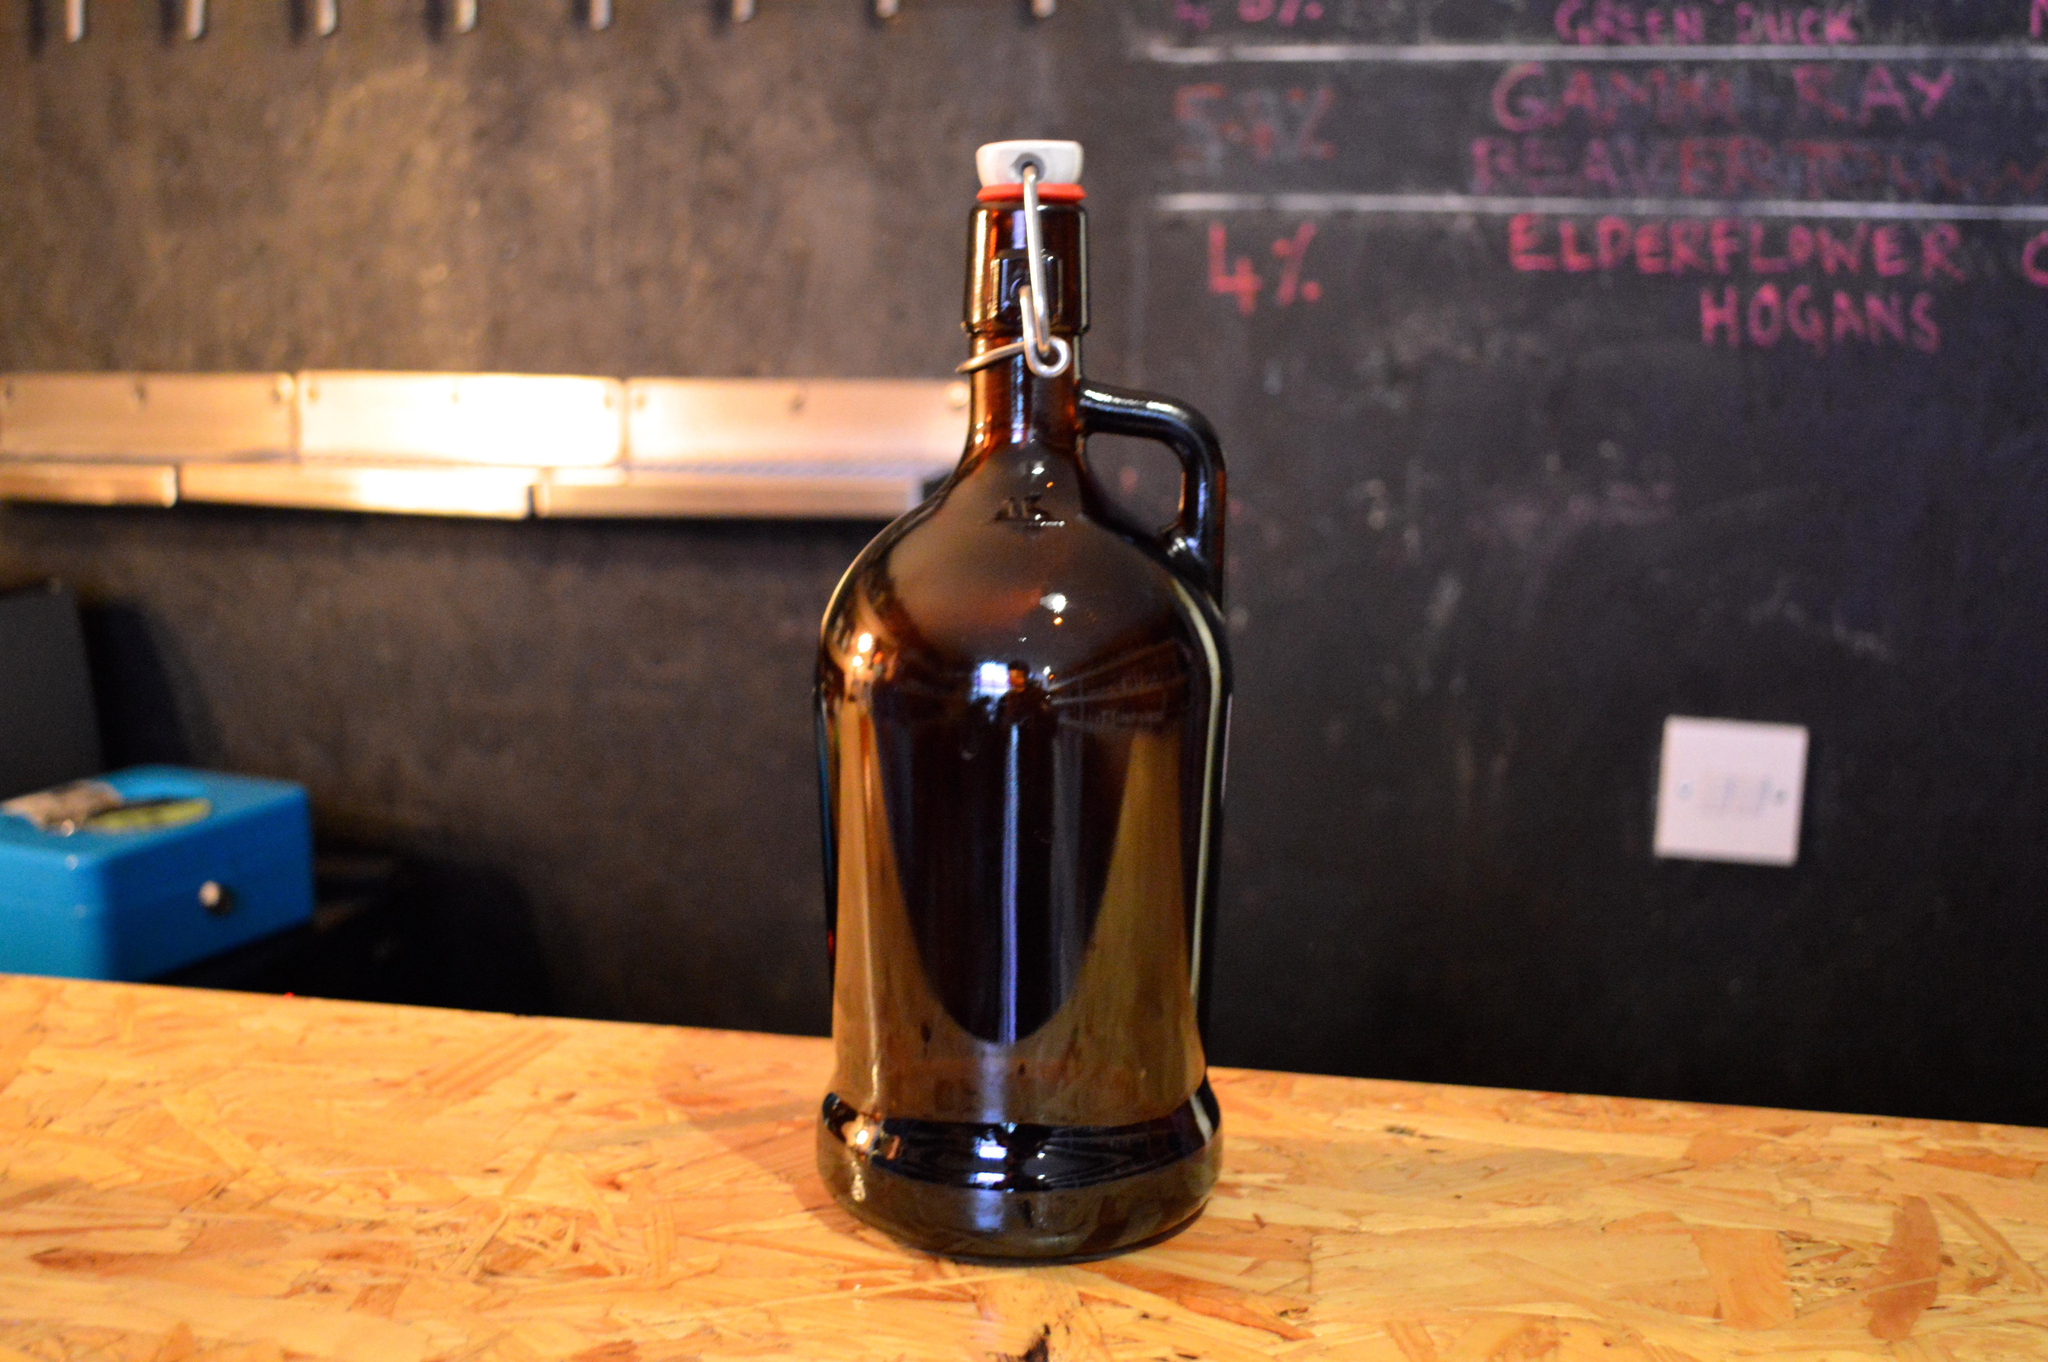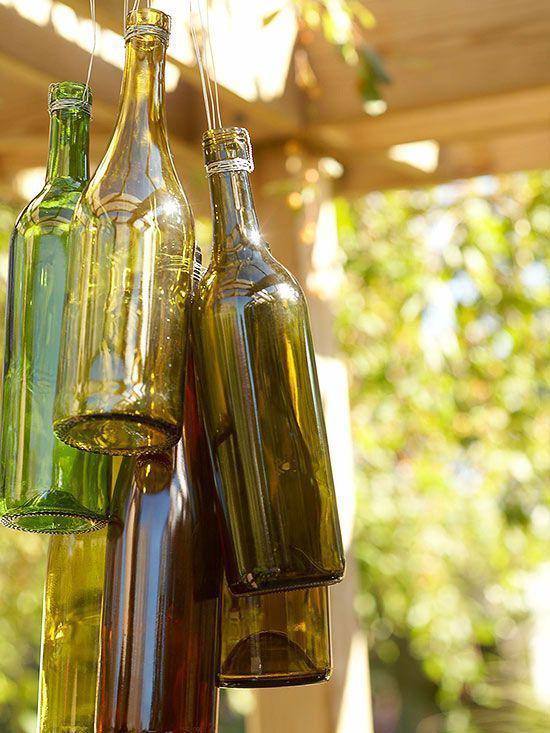The first image is the image on the left, the second image is the image on the right. For the images displayed, is the sentence "People are clinking two brown bottles together in one of the images." factually correct? Answer yes or no. No. The first image is the image on the left, the second image is the image on the right. Assess this claim about the two images: "Both images are taken outdoors and in at least one of them, a campfire with food is in the background.". Correct or not? Answer yes or no. No. 